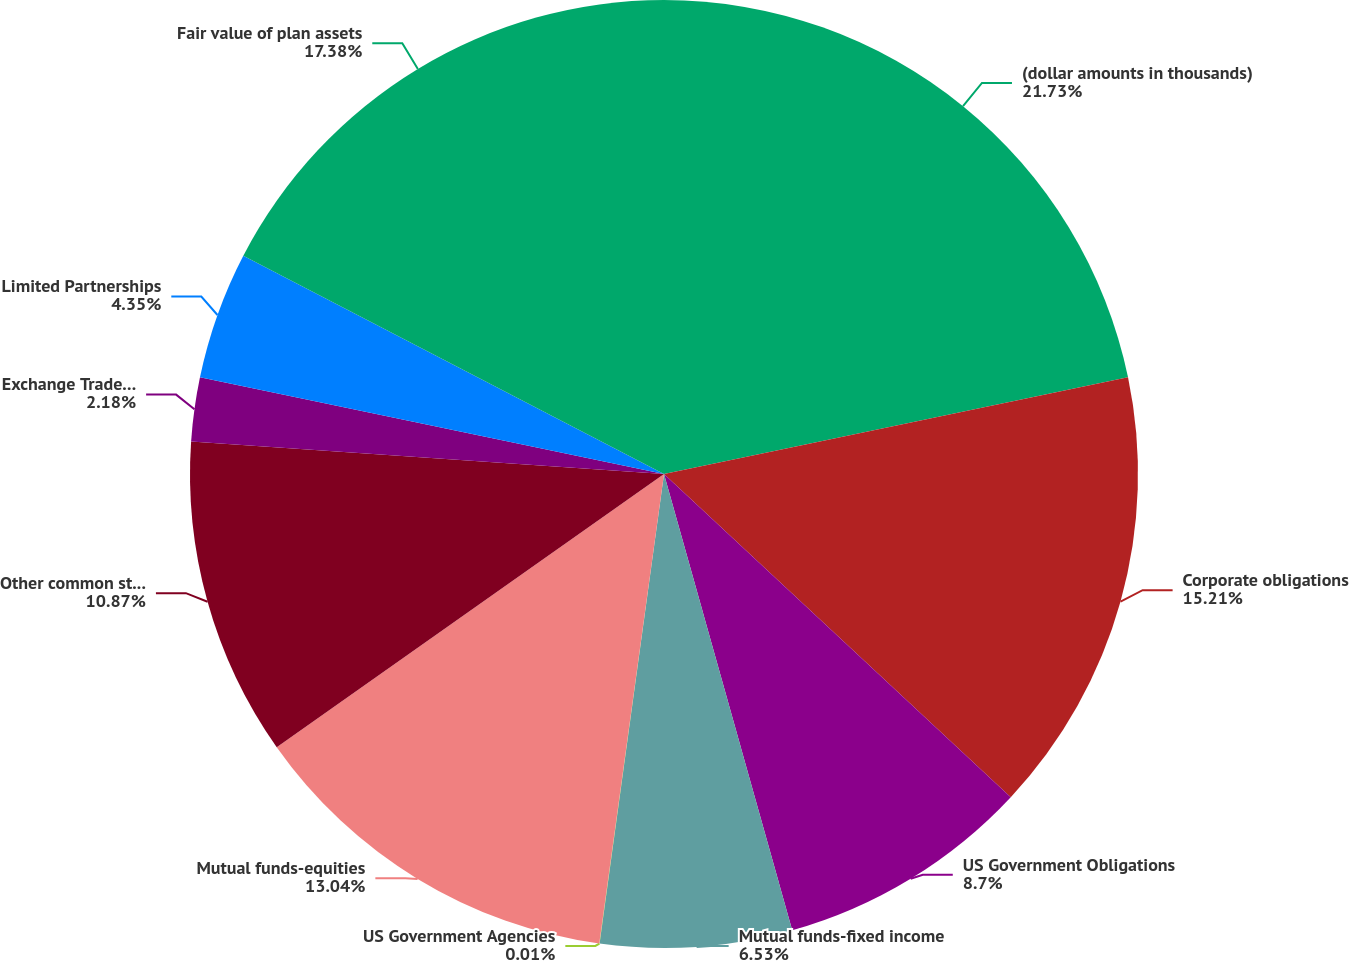<chart> <loc_0><loc_0><loc_500><loc_500><pie_chart><fcel>(dollar amounts in thousands)<fcel>Corporate obligations<fcel>US Government Obligations<fcel>Mutual funds-fixed income<fcel>US Government Agencies<fcel>Mutual funds-equities<fcel>Other common stock<fcel>Exchange Traded Funds<fcel>Limited Partnerships<fcel>Fair value of plan assets<nl><fcel>21.73%<fcel>15.21%<fcel>8.7%<fcel>6.53%<fcel>0.01%<fcel>13.04%<fcel>10.87%<fcel>2.18%<fcel>4.35%<fcel>17.38%<nl></chart> 